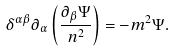Convert formula to latex. <formula><loc_0><loc_0><loc_500><loc_500>\delta ^ { \alpha \beta } \partial _ { \alpha } \left ( \frac { \partial _ { \beta } \Psi } { n ^ { 2 } } \right ) = - m ^ { 2 } \Psi .</formula> 